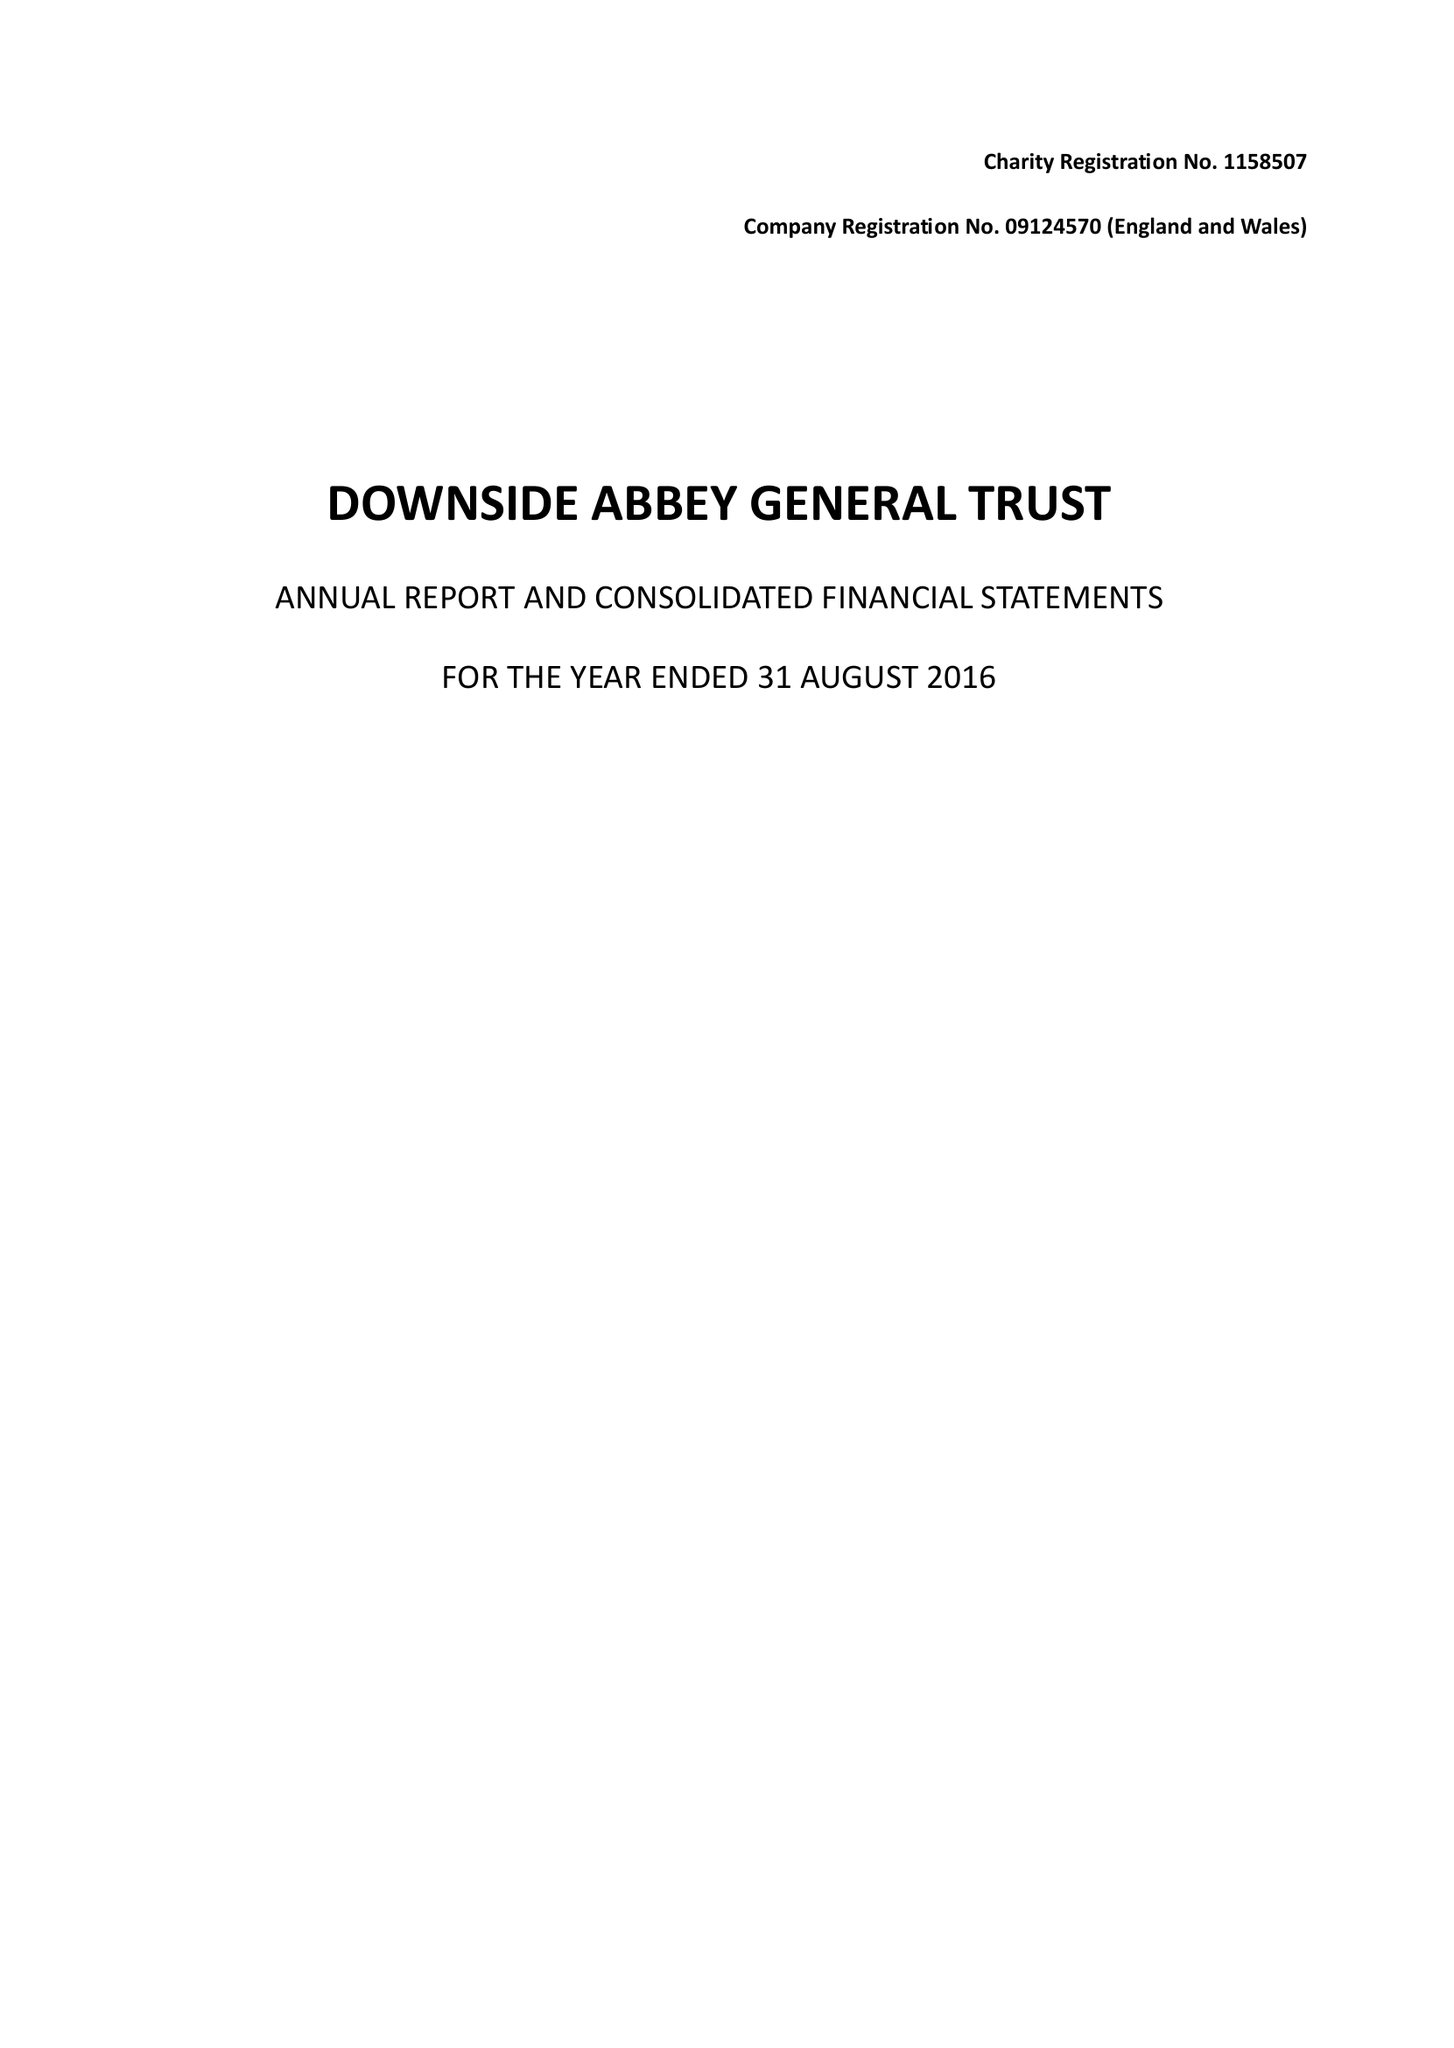What is the value for the report_date?
Answer the question using a single word or phrase. 2016-08-31 